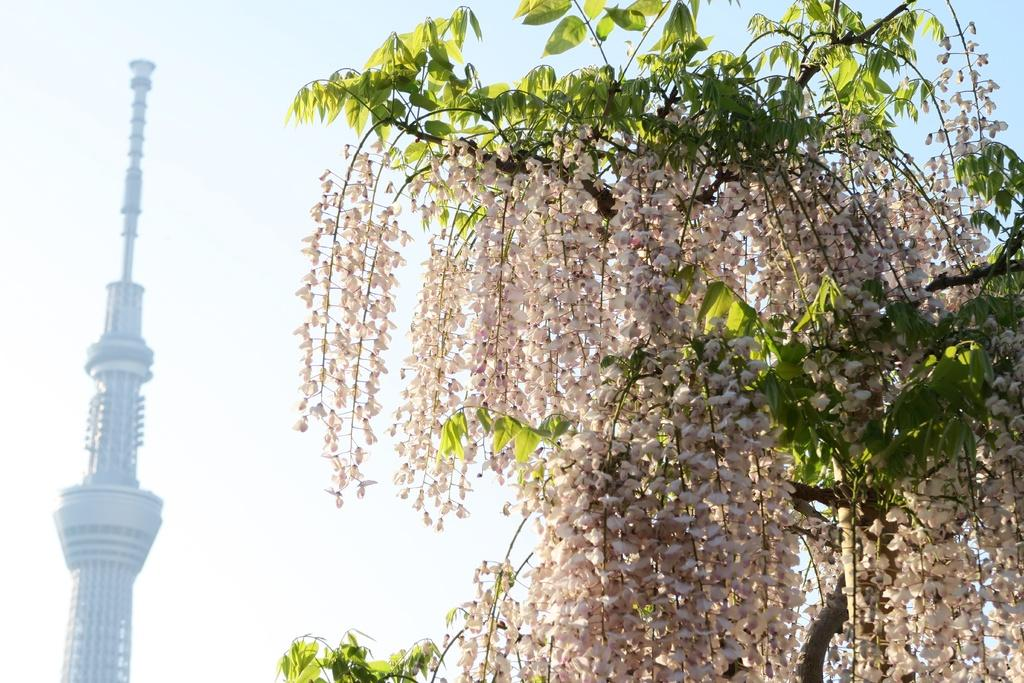What type of vegetation is on the right side of the image? There is a tree on the right side of the image. What structure is located on the left side of the image? There is a tower on the left side of the image. What is visible in the background of the image? The sky is visible in the background of the image. What type of ear is visible on the tree in the image? There is no ear present in the image; it features a tree and a tower. How many sticks can be seen leaning against the tower in the image? There are no sticks present in the image. 